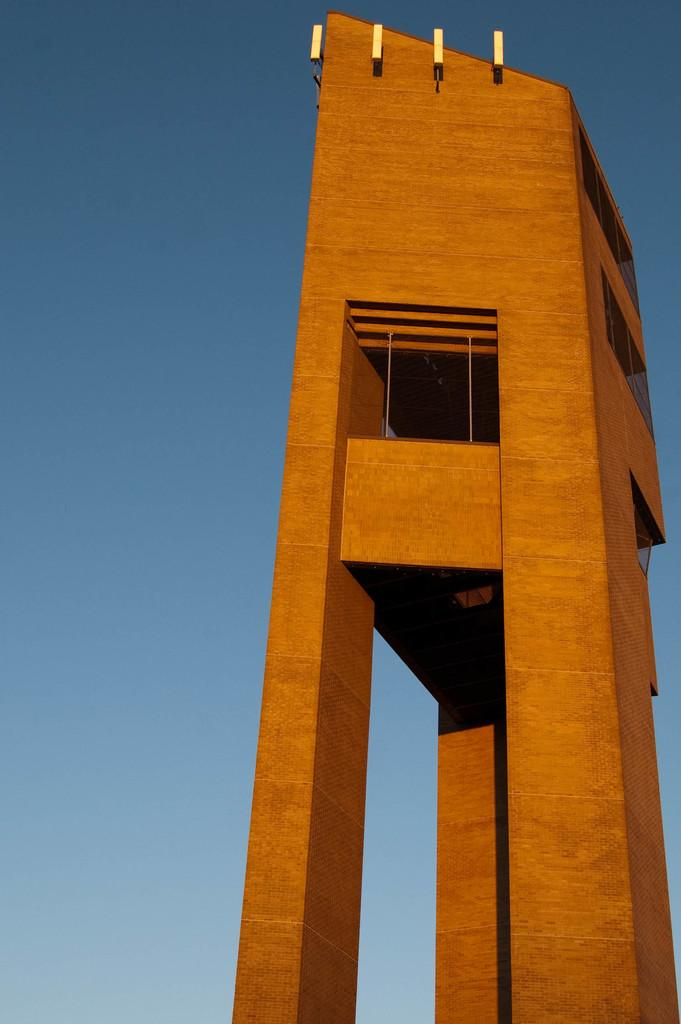What type of structure is present in the image? There is a building in the image. What is the color of the building? The building is brown in color. What can be seen in the background of the image? There is a sky visible in the background of the image. How many rabbits can be seen playing in the basin in the image? There are no rabbits or basins present in the image; it features a brown building with a visible sky in the background. 